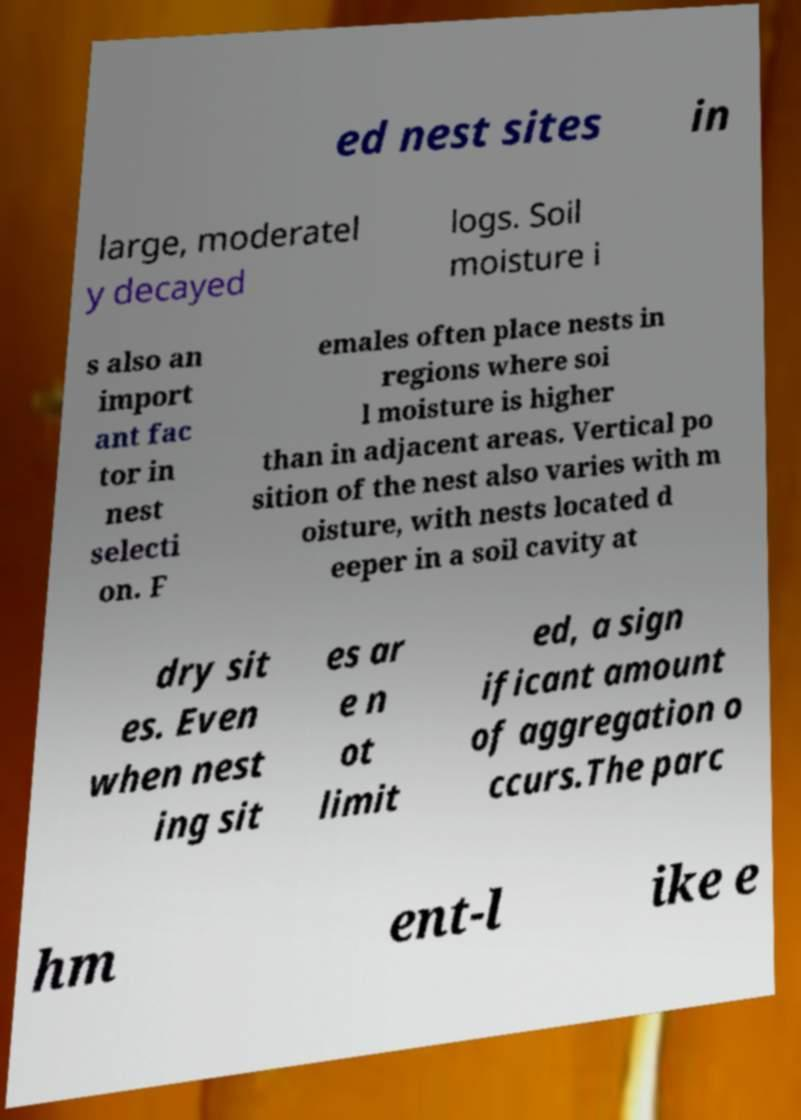Can you read and provide the text displayed in the image?This photo seems to have some interesting text. Can you extract and type it out for me? ed nest sites in large, moderatel y decayed logs. Soil moisture i s also an import ant fac tor in nest selecti on. F emales often place nests in regions where soi l moisture is higher than in adjacent areas. Vertical po sition of the nest also varies with m oisture, with nests located d eeper in a soil cavity at dry sit es. Even when nest ing sit es ar e n ot limit ed, a sign ificant amount of aggregation o ccurs.The parc hm ent-l ike e 